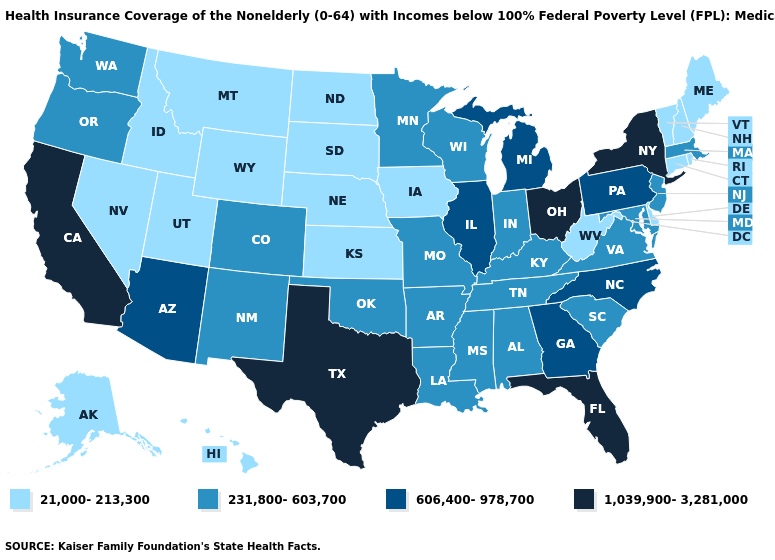Which states have the highest value in the USA?
Write a very short answer. California, Florida, New York, Ohio, Texas. What is the value of Florida?
Be succinct. 1,039,900-3,281,000. What is the highest value in the South ?
Short answer required. 1,039,900-3,281,000. Among the states that border Arizona , does California have the highest value?
Quick response, please. Yes. Name the states that have a value in the range 1,039,900-3,281,000?
Keep it brief. California, Florida, New York, Ohio, Texas. How many symbols are there in the legend?
Be succinct. 4. What is the value of Utah?
Write a very short answer. 21,000-213,300. Does Pennsylvania have the lowest value in the Northeast?
Give a very brief answer. No. Is the legend a continuous bar?
Quick response, please. No. How many symbols are there in the legend?
Write a very short answer. 4. Name the states that have a value in the range 231,800-603,700?
Keep it brief. Alabama, Arkansas, Colorado, Indiana, Kentucky, Louisiana, Maryland, Massachusetts, Minnesota, Mississippi, Missouri, New Jersey, New Mexico, Oklahoma, Oregon, South Carolina, Tennessee, Virginia, Washington, Wisconsin. What is the lowest value in the South?
Be succinct. 21,000-213,300. What is the value of Alaska?
Be succinct. 21,000-213,300. What is the value of Rhode Island?
Short answer required. 21,000-213,300. Which states hav the highest value in the MidWest?
Be succinct. Ohio. 